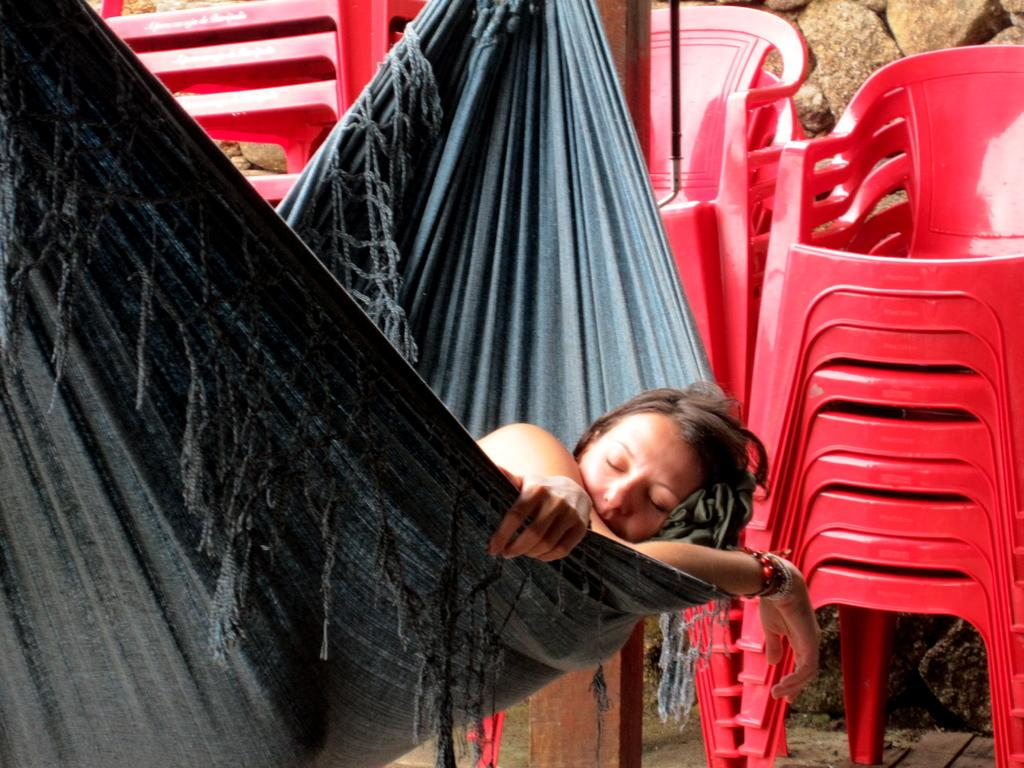Who is present in the image? There is a woman in the image. What is the woman doing in the image? The woman is sleeping in a swing. What can be seen in the background of the image? There are rocks, chairs, and other objects in the background of the image. What news is the woman reading while sleeping in the swing? The woman is sleeping in the swing and not reading any news in the image. How many potatoes can be seen in the image? There are no potatoes present in the image. 